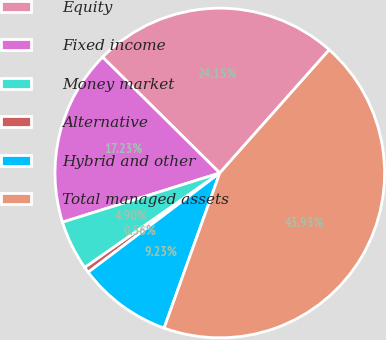<chart> <loc_0><loc_0><loc_500><loc_500><pie_chart><fcel>Equity<fcel>Fixed income<fcel>Money market<fcel>Alternative<fcel>Hybrid and other<fcel>Total managed assets<nl><fcel>24.15%<fcel>17.23%<fcel>4.9%<fcel>0.56%<fcel>9.23%<fcel>43.93%<nl></chart> 